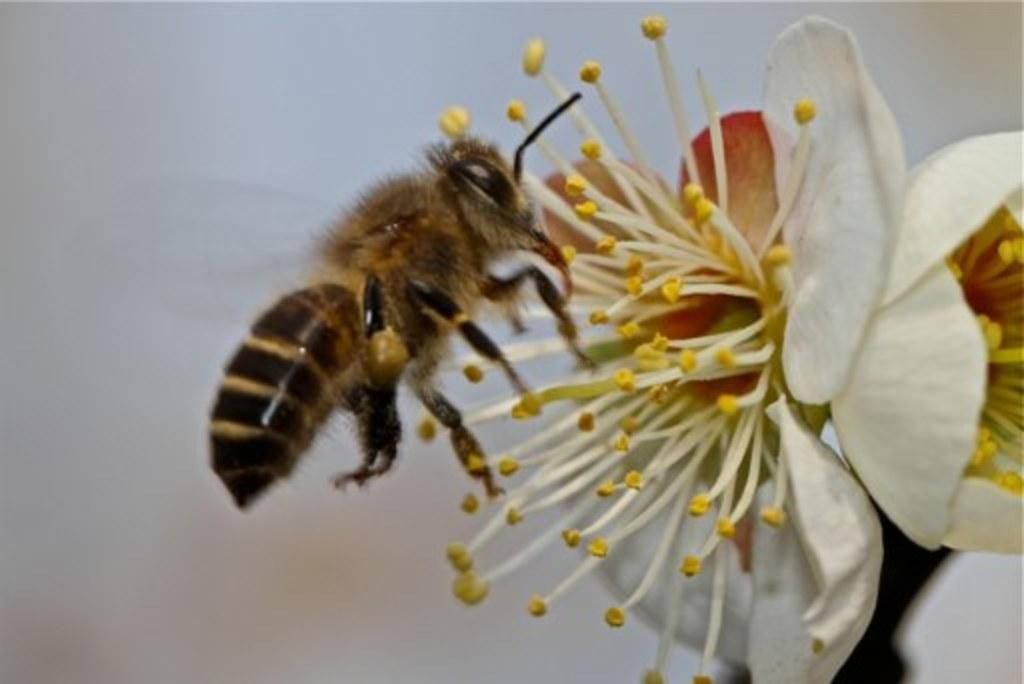What type of creature is in the image? There is an insect in the image. What colors can be seen on the insect? The insect has cream, black, and brown colors. Where is the insect located in the image? The insect is on a flower. What colors can be seen on the flower? The flower has cream, yellow, and red colors. How would you describe the background of the image? The background of the image is blurry. Can you see any chairs in the image? There are no chairs present in the image. What type of ocean can be seen in the image? There is no ocean present in the image; it features an insect on a flower. 